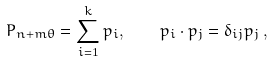Convert formula to latex. <formula><loc_0><loc_0><loc_500><loc_500>P _ { n + m \theta } = \sum _ { i = 1 } ^ { k } p _ { i } , \quad p _ { i } \cdot p _ { j } = \delta _ { i j } p _ { j } \, ,</formula> 